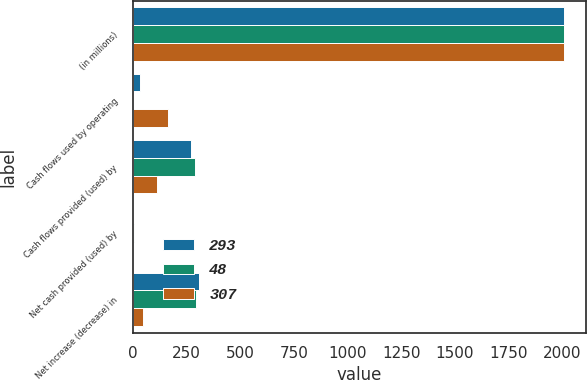Convert chart to OTSL. <chart><loc_0><loc_0><loc_500><loc_500><stacked_bar_chart><ecel><fcel>(in millions)<fcel>Cash flows used by operating<fcel>Cash flows provided (used) by<fcel>Net cash provided (used) by<fcel>Net increase (decrease) in<nl><fcel>293<fcel>2009<fcel>32<fcel>273<fcel>2<fcel>307<nl><fcel>48<fcel>2008<fcel>3<fcel>290<fcel>6<fcel>293<nl><fcel>307<fcel>2007<fcel>165<fcel>114<fcel>3<fcel>48<nl></chart> 